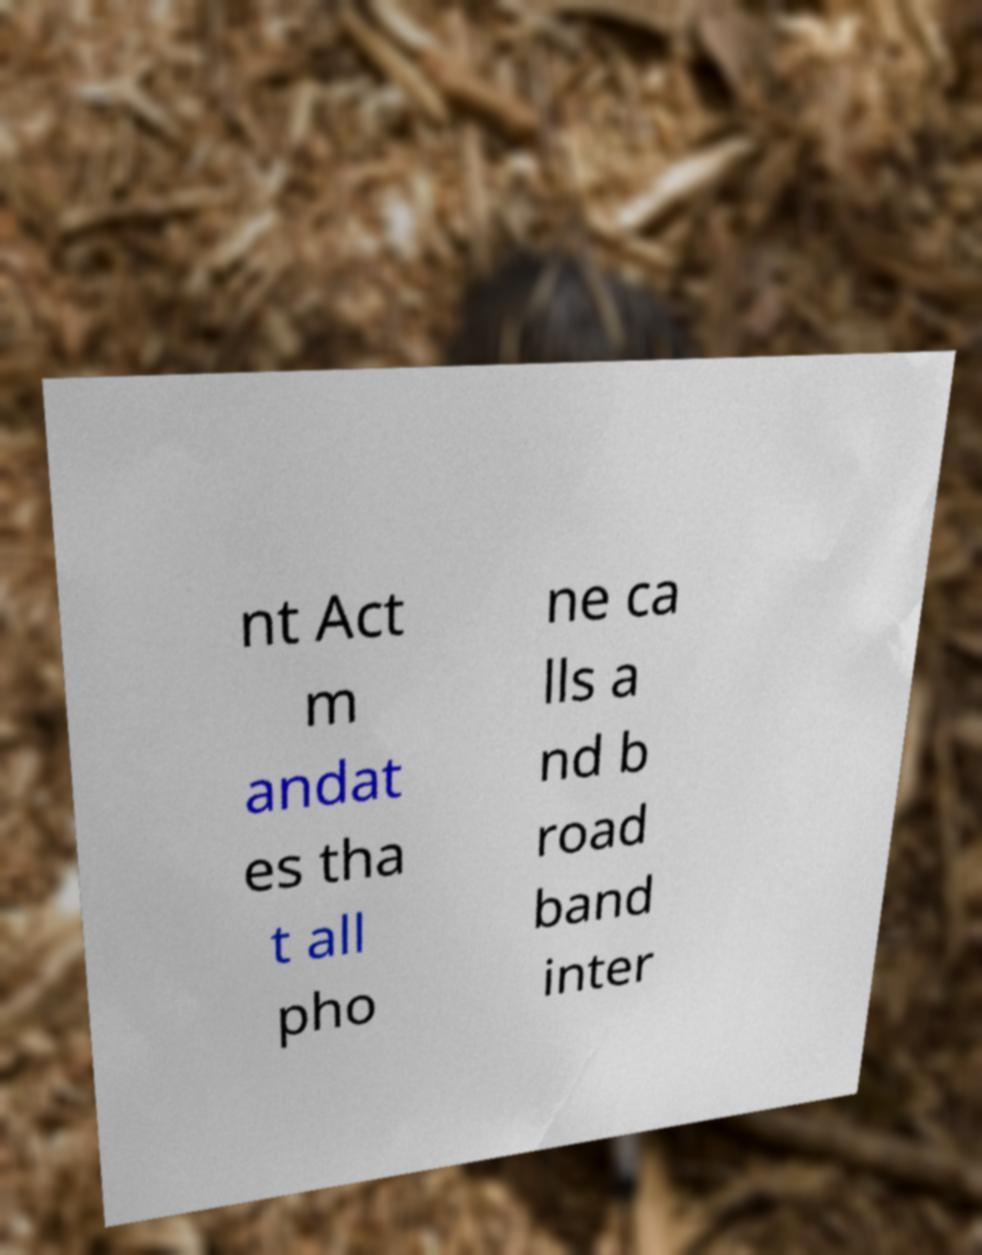Can you accurately transcribe the text from the provided image for me? nt Act m andat es tha t all pho ne ca lls a nd b road band inter 